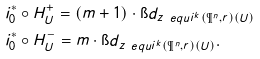<formula> <loc_0><loc_0><loc_500><loc_500>& i _ { 0 } ^ { * } \circ H ^ { + } _ { U } = ( m + 1 ) \cdot \i d _ { z _ { \ } e q u i ^ { k } ( \P ^ { n } , r ) ( U ) } \\ & i _ { 0 } ^ { * } \circ H ^ { - } _ { U } = m \cdot \i d _ { z _ { \ } e q u i ^ { k } ( \P ^ { n } , r ) ( U ) } .</formula> 